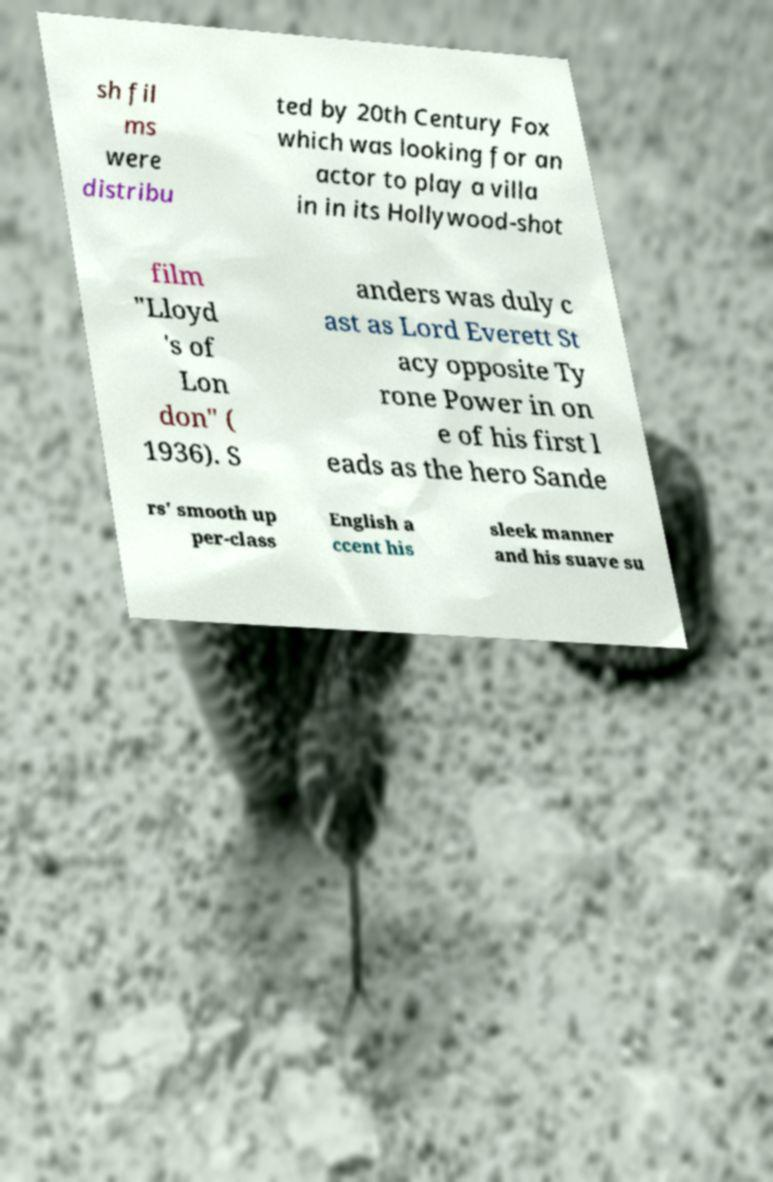Could you assist in decoding the text presented in this image and type it out clearly? sh fil ms were distribu ted by 20th Century Fox which was looking for an actor to play a villa in in its Hollywood-shot film "Lloyd 's of Lon don" ( 1936). S anders was duly c ast as Lord Everett St acy opposite Ty rone Power in on e of his first l eads as the hero Sande rs' smooth up per-class English a ccent his sleek manner and his suave su 